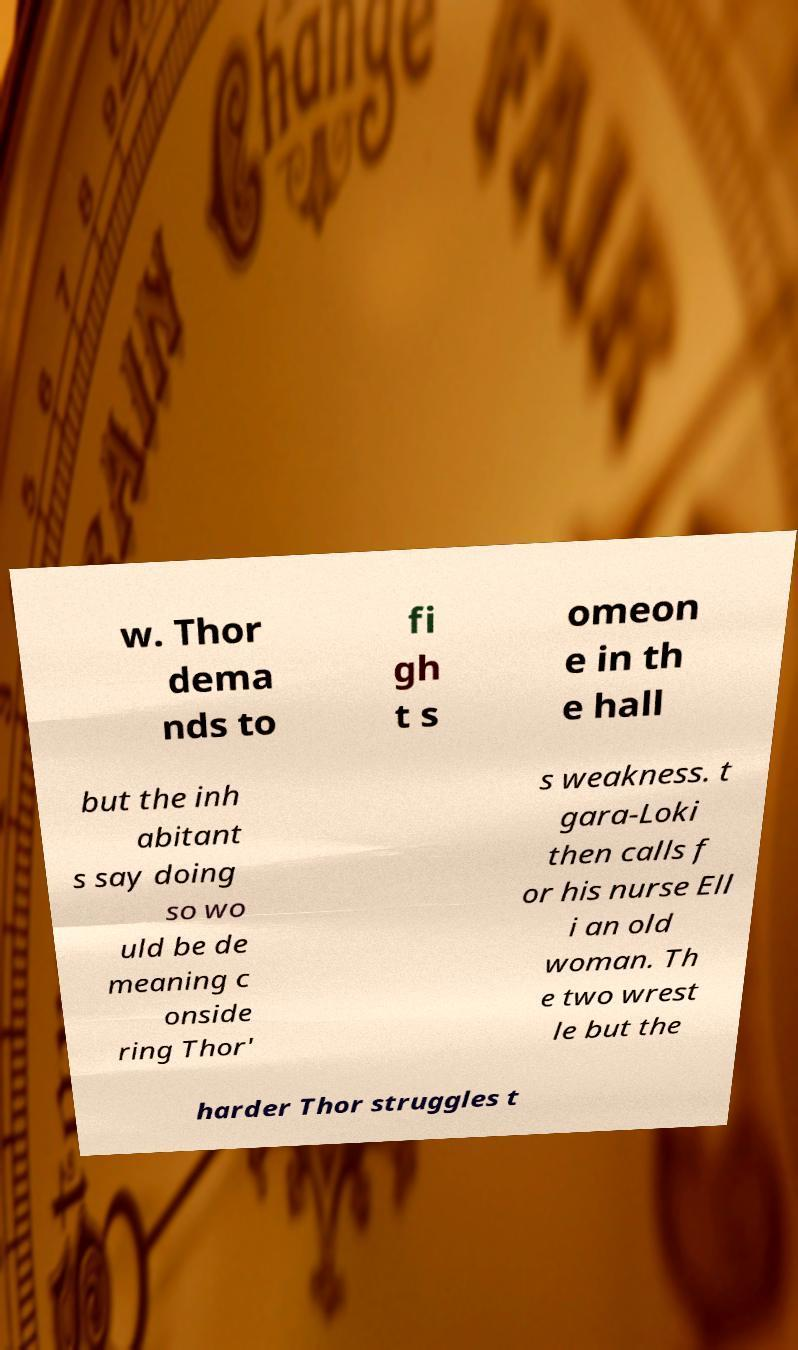Can you accurately transcribe the text from the provided image for me? w. Thor dema nds to fi gh t s omeon e in th e hall but the inh abitant s say doing so wo uld be de meaning c onside ring Thor' s weakness. t gara-Loki then calls f or his nurse Ell i an old woman. Th e two wrest le but the harder Thor struggles t 